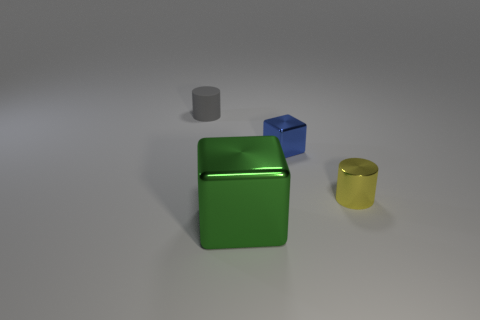There is a metal block in front of the small metal object that is behind the small yellow thing; how big is it?
Your response must be concise. Large. What number of small gray cylinders are there?
Provide a short and direct response. 1. How many small yellow cylinders are made of the same material as the small gray cylinder?
Your response must be concise. 0. What is the size of the other matte thing that is the same shape as the small yellow object?
Offer a terse response. Small. What material is the large green object?
Provide a short and direct response. Metal. There is a thing that is in front of the cylinder in front of the tiny cylinder on the left side of the tiny yellow metallic cylinder; what is its material?
Your answer should be compact. Metal. Is there anything else that is the same shape as the small gray rubber thing?
Make the answer very short. Yes. What is the color of the metallic thing that is the same shape as the tiny matte object?
Your answer should be very brief. Yellow. Does the shiny thing that is left of the small blue shiny object have the same color as the cylinder to the right of the large block?
Provide a short and direct response. No. Are there more gray matte cylinders on the left side of the yellow metal cylinder than tiny blue metal things?
Offer a terse response. No. 